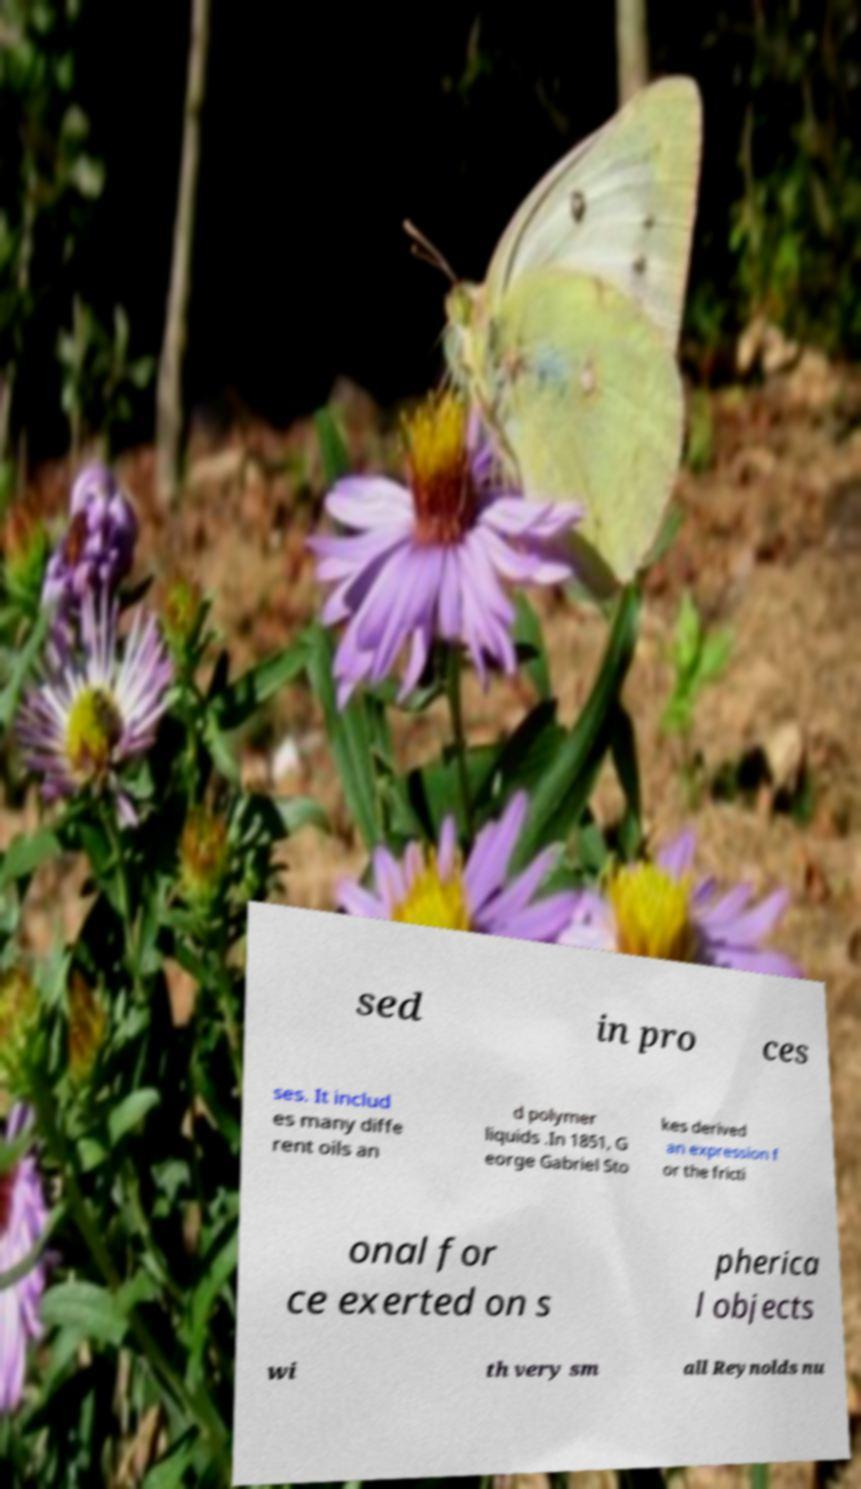There's text embedded in this image that I need extracted. Can you transcribe it verbatim? sed in pro ces ses. It includ es many diffe rent oils an d polymer liquids .In 1851, G eorge Gabriel Sto kes derived an expression f or the fricti onal for ce exerted on s pherica l objects wi th very sm all Reynolds nu 